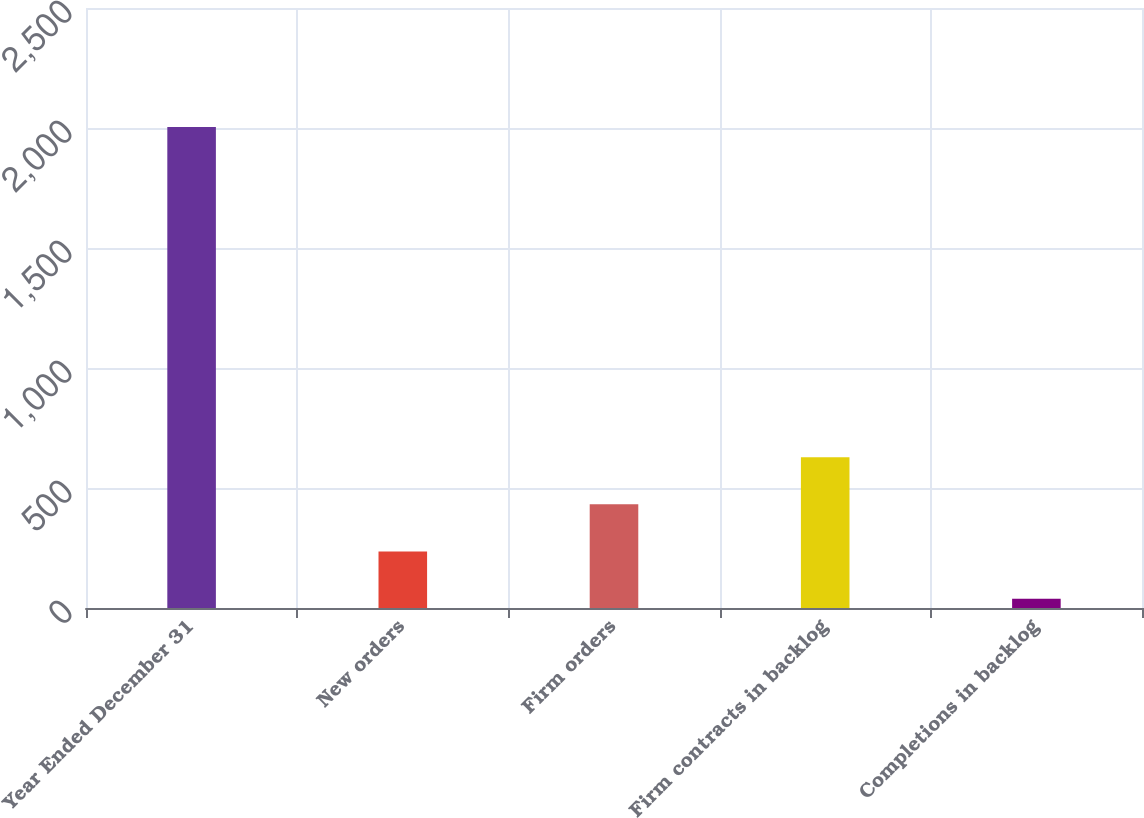Convert chart. <chart><loc_0><loc_0><loc_500><loc_500><bar_chart><fcel>Year Ended December 31<fcel>New orders<fcel>Firm orders<fcel>Firm contracts in backlog<fcel>Completions in backlog<nl><fcel>2004<fcel>235.5<fcel>432<fcel>628.5<fcel>39<nl></chart> 